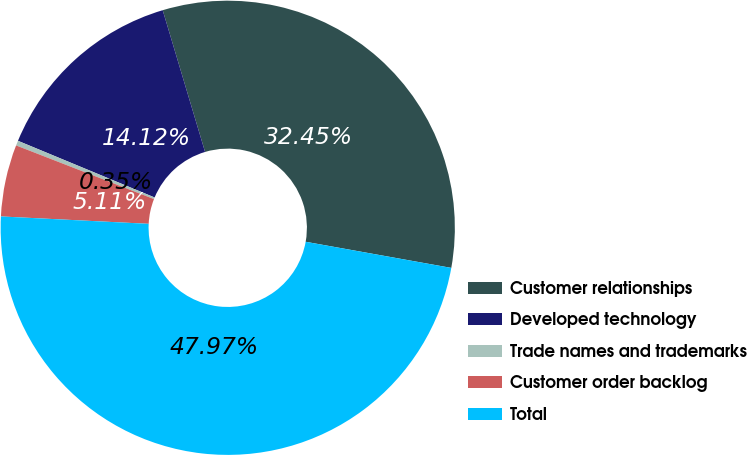Convert chart. <chart><loc_0><loc_0><loc_500><loc_500><pie_chart><fcel>Customer relationships<fcel>Developed technology<fcel>Trade names and trademarks<fcel>Customer order backlog<fcel>Total<nl><fcel>32.45%<fcel>14.12%<fcel>0.35%<fcel>5.11%<fcel>47.97%<nl></chart> 